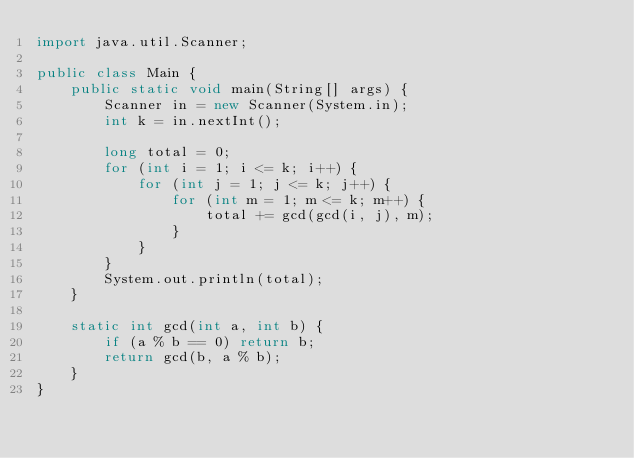<code> <loc_0><loc_0><loc_500><loc_500><_Java_>import java.util.Scanner;

public class Main {
    public static void main(String[] args) {
        Scanner in = new Scanner(System.in);
        int k = in.nextInt();

        long total = 0;
        for (int i = 1; i <= k; i++) {
            for (int j = 1; j <= k; j++) {
                for (int m = 1; m <= k; m++) {
                    total += gcd(gcd(i, j), m);
                }
            }
        }
        System.out.println(total);
    }

    static int gcd(int a, int b) {
        if (a % b == 0) return b;
        return gcd(b, a % b);
    }
}
</code> 